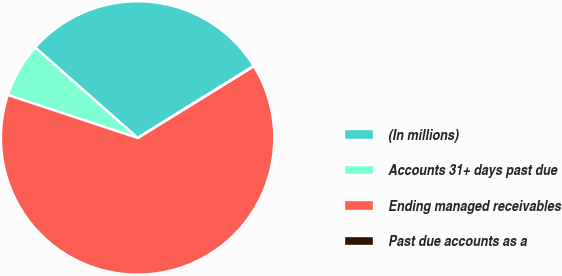Convert chart. <chart><loc_0><loc_0><loc_500><loc_500><pie_chart><fcel>(In millions)<fcel>Accounts 31+ days past due<fcel>Ending managed receivables<fcel>Past due accounts as a<nl><fcel>29.64%<fcel>6.43%<fcel>63.89%<fcel>0.04%<nl></chart> 